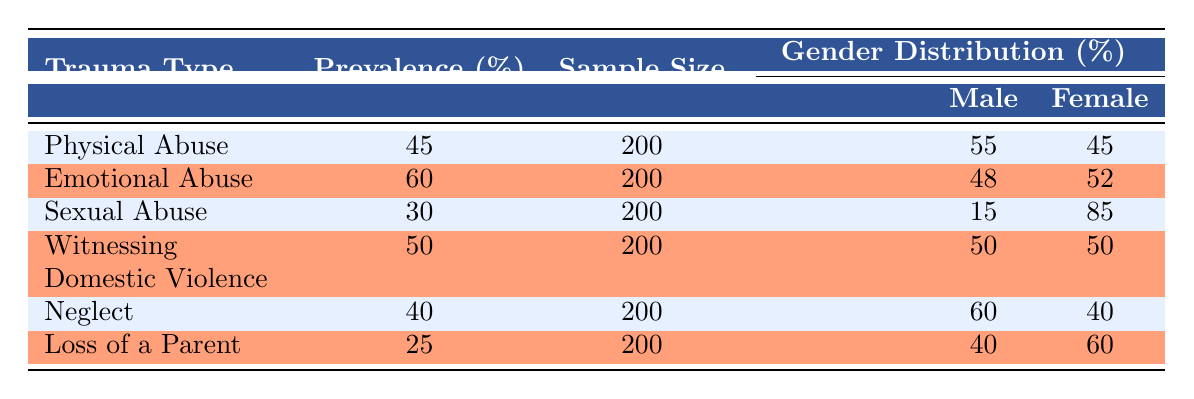What is the prevalence percentage of Physical Abuse among juvenile offenders? The table shows that the prevalence percentage for Physical Abuse is specifically mentioned in the second column, where it states 45%.
Answer: 45% Which trauma type has the highest prevalence percentage among juvenile offenders? By examining the prevalence percentages listed in the table, Emotional Abuse shows the highest percentage at 60%.
Answer: Emotional Abuse What is the sample size for each type of trauma in this study? The sample size for all trauma types listed in the table is consistent and appears as 200 in the third column, regardless of trauma type.
Answer: 200 Is the percentage of males who experienced Sexual Abuse higher than the percentage of females? For Sexual Abuse, the table indicates that 15% of males and 85% of females experienced this trauma, confirming that a higher percentage of females is reported. Therefore, the statement is false.
Answer: No What is the average prevalence percentage of childhood trauma types listed in the table? To find the average, sum the prevalence percentages: 45 + 60 + 30 + 50 + 40 + 25 = 250. Then divide by the number of trauma types (6): 250/6 = approximately 41.67.
Answer: Approximately 41.67 How many trauma types have a prevalence percentage of 40% or higher? Reviewing the table, the trauma types that meet or exceed 40% are Physical Abuse (45%), Emotional Abuse (60%), Witnessing Domestic Violence (50%), Neglect (40%). Thus, there are four trauma types in this category.
Answer: 4 Does the percentage of males who experienced Witnessing Domestic Violence equal the percentage of females? The table shows that both males and females who experienced Witnessing Domestic Violence have equal percentages of 50%. Hence, the answer is yes.
Answer: Yes What is the difference in prevalence percentage between Emotional Abuse and Loss of a Parent? The difference is calculated by subtracting the prevalence of Loss of a Parent (25%) from Emotional Abuse (60%), resulting in a difference of 60 - 25 = 35%.
Answer: 35% 